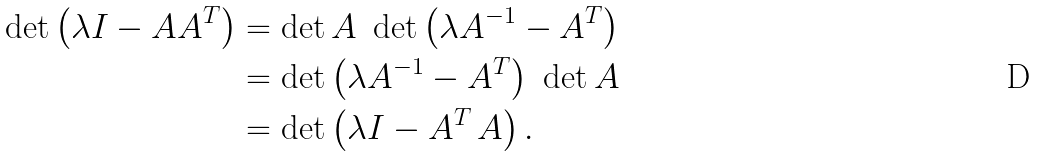Convert formula to latex. <formula><loc_0><loc_0><loc_500><loc_500>\det \left ( \lambda I - A A ^ { T } \right ) & = \det A \ \det \left ( \lambda A ^ { - 1 } - A ^ { T } \right ) \\ & = \det \left ( \lambda A ^ { - 1 } - A ^ { T } \right ) \ \det A \\ & = \det \left ( \lambda I - A ^ { T } \, A \right ) .</formula> 